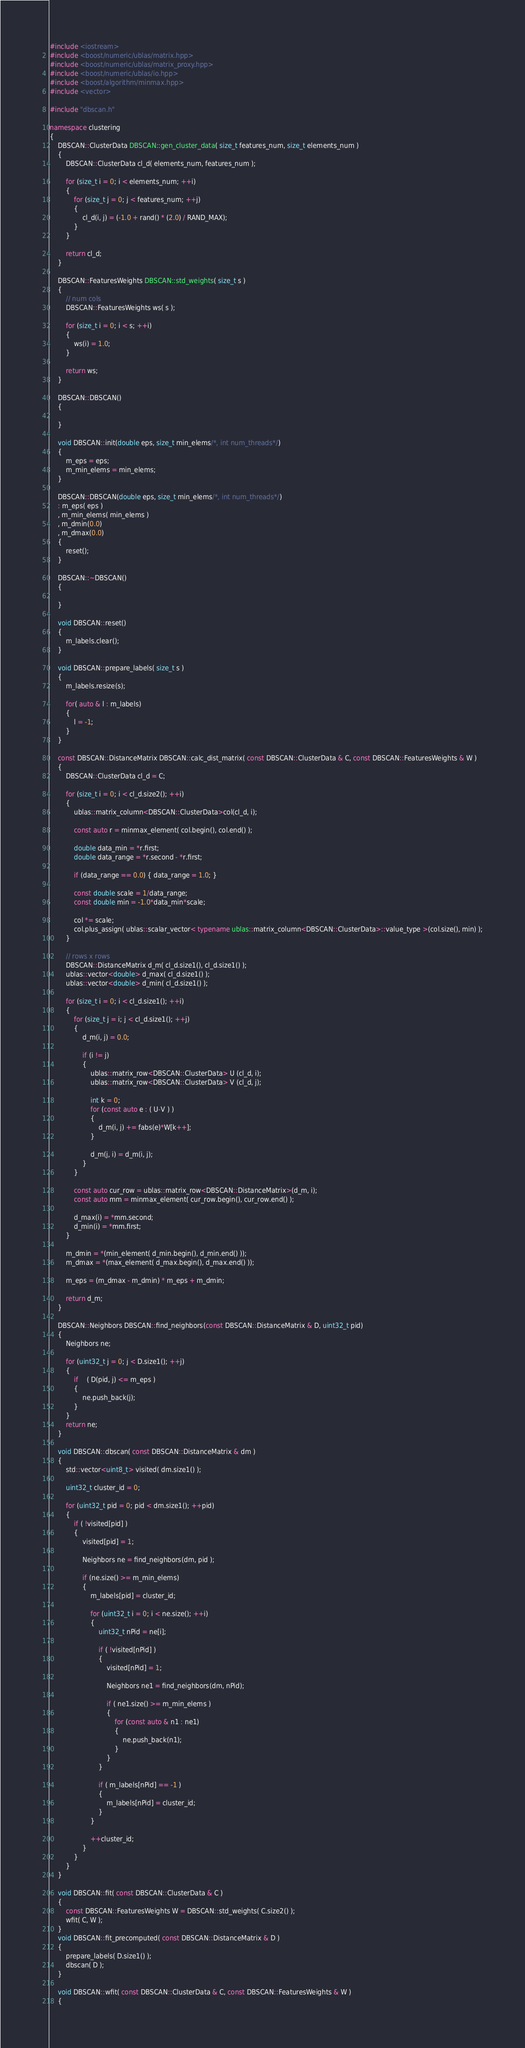<code> <loc_0><loc_0><loc_500><loc_500><_C++_>#include <iostream>
#include <boost/numeric/ublas/matrix.hpp>
#include <boost/numeric/ublas/matrix_proxy.hpp>
#include <boost/numeric/ublas/io.hpp>
#include <boost/algorithm/minmax.hpp>
#include <vector>

#include "dbscan.h"

namespace clustering
{
	DBSCAN::ClusterData DBSCAN::gen_cluster_data( size_t features_num, size_t elements_num )
	{
		DBSCAN::ClusterData cl_d( elements_num, features_num );

		for (size_t i = 0; i < elements_num; ++i)
		{
			for (size_t j = 0; j < features_num; ++j)	
			{
				cl_d(i, j) = (-1.0 + rand() * (2.0) / RAND_MAX);
			}
		}

		return cl_d;
	}

	DBSCAN::FeaturesWeights DBSCAN::std_weights( size_t s )
	{
		// num cols
		DBSCAN::FeaturesWeights ws( s );

		for (size_t i = 0; i < s; ++i)
		{
			ws(i) = 1.0;
		}

		return ws;
	}

	DBSCAN::DBSCAN()
	{

	}

	void DBSCAN::init(double eps, size_t min_elems/*, int num_threads*/)
	{
		m_eps = eps;
		m_min_elems = min_elems;
	}

	DBSCAN::DBSCAN(double eps, size_t min_elems/*, int num_threads*/)
	: m_eps( eps )
	, m_min_elems( min_elems )
	, m_dmin(0.0)
	, m_dmax(0.0)
	{
		reset();
	}

	DBSCAN::~DBSCAN()
	{

	}

	void DBSCAN::reset()
	{
		m_labels.clear();
	}

	void DBSCAN::prepare_labels( size_t s )
	{
		m_labels.resize(s);

		for( auto & l : m_labels)
		{
			l = -1;
		}
	}

	const DBSCAN::DistanceMatrix DBSCAN::calc_dist_matrix( const DBSCAN::ClusterData & C, const DBSCAN::FeaturesWeights & W )
	{
		DBSCAN::ClusterData cl_d = C;

		for (size_t i = 0; i < cl_d.size2(); ++i)
		{
			ublas::matrix_column<DBSCAN::ClusterData>col(cl_d, i);

			const auto r = minmax_element( col.begin(), col.end() );

			double data_min = *r.first;
			double data_range = *r.second - *r.first;

			if (data_range == 0.0) { data_range = 1.0; }

			const double scale = 1/data_range;
			const double min = -1.0*data_min*scale;

			col *= scale;
			col.plus_assign( ublas::scalar_vector< typename ublas::matrix_column<DBSCAN::ClusterData>::value_type >(col.size(), min) );
		}

		// rows x rows
		DBSCAN::DistanceMatrix d_m( cl_d.size1(), cl_d.size1() );
		ublas::vector<double> d_max( cl_d.size1() );
		ublas::vector<double> d_min( cl_d.size1() );

		for (size_t i = 0; i < cl_d.size1(); ++i)
		{
			for (size_t j = i; j < cl_d.size1(); ++j)	
			{
				d_m(i, j) = 0.0;

				if (i != j)
				{
					ublas::matrix_row<DBSCAN::ClusterData> U (cl_d, i);
					ublas::matrix_row<DBSCAN::ClusterData> V (cl_d, j);

					int k = 0;
					for (const auto e : ( U-V ) )
					{
						d_m(i, j) += fabs(e)*W[k++];
					}

					d_m(j, i) = d_m(i, j);
				}
			}

			const auto cur_row = ublas::matrix_row<DBSCAN::DistanceMatrix>(d_m, i);
			const auto mm = minmax_element( cur_row.begin(), cur_row.end() );

			d_max(i) = *mm.second;
			d_min(i) = *mm.first;
		}

		m_dmin = *(min_element( d_min.begin(), d_min.end() ));
		m_dmax = *(max_element( d_max.begin(), d_max.end() ));

		m_eps = (m_dmax - m_dmin) * m_eps + m_dmin;

		return d_m;
	}

	DBSCAN::Neighbors DBSCAN::find_neighbors(const DBSCAN::DistanceMatrix & D, uint32_t pid)
	{
		Neighbors ne;

		for (uint32_t j = 0; j < D.size1(); ++j)
		{
			if 	( D(pid, j) <= m_eps )
			{
				ne.push_back(j);
			}
		}
		return ne;
	}

	void DBSCAN::dbscan( const DBSCAN::DistanceMatrix & dm )
	{
		std::vector<uint8_t> visited( dm.size1() );

		uint32_t cluster_id = 0;

		for (uint32_t pid = 0; pid < dm.size1(); ++pid)
		{
			if ( !visited[pid] )
			{  
				visited[pid] = 1;

				Neighbors ne = find_neighbors(dm, pid );

				if (ne.size() >= m_min_elems)
				{
					m_labels[pid] = cluster_id;

					for (uint32_t i = 0; i < ne.size(); ++i)
					{
						uint32_t nPid = ne[i];

						if ( !visited[nPid] )
						{
							visited[nPid] = 1;

							Neighbors ne1 = find_neighbors(dm, nPid);

							if ( ne1.size() >= m_min_elems )
							{
								for (const auto & n1 : ne1)
								{
									ne.push_back(n1);
								}
							}
						}

						if ( m_labels[nPid] == -1 )
						{
							m_labels[nPid] = cluster_id;
						}
					}

					++cluster_id;
				}
			}
		}
	}

	void DBSCAN::fit( const DBSCAN::ClusterData & C ) 
	{
		const DBSCAN::FeaturesWeights W = DBSCAN::std_weights( C.size2() );
		wfit( C, W );
	}
	void DBSCAN::fit_precomputed( const DBSCAN::DistanceMatrix & D ) 
	{
		prepare_labels( D.size1() );
		dbscan( D );
	}

	void DBSCAN::wfit( const DBSCAN::ClusterData & C, const DBSCAN::FeaturesWeights & W )
	{</code> 